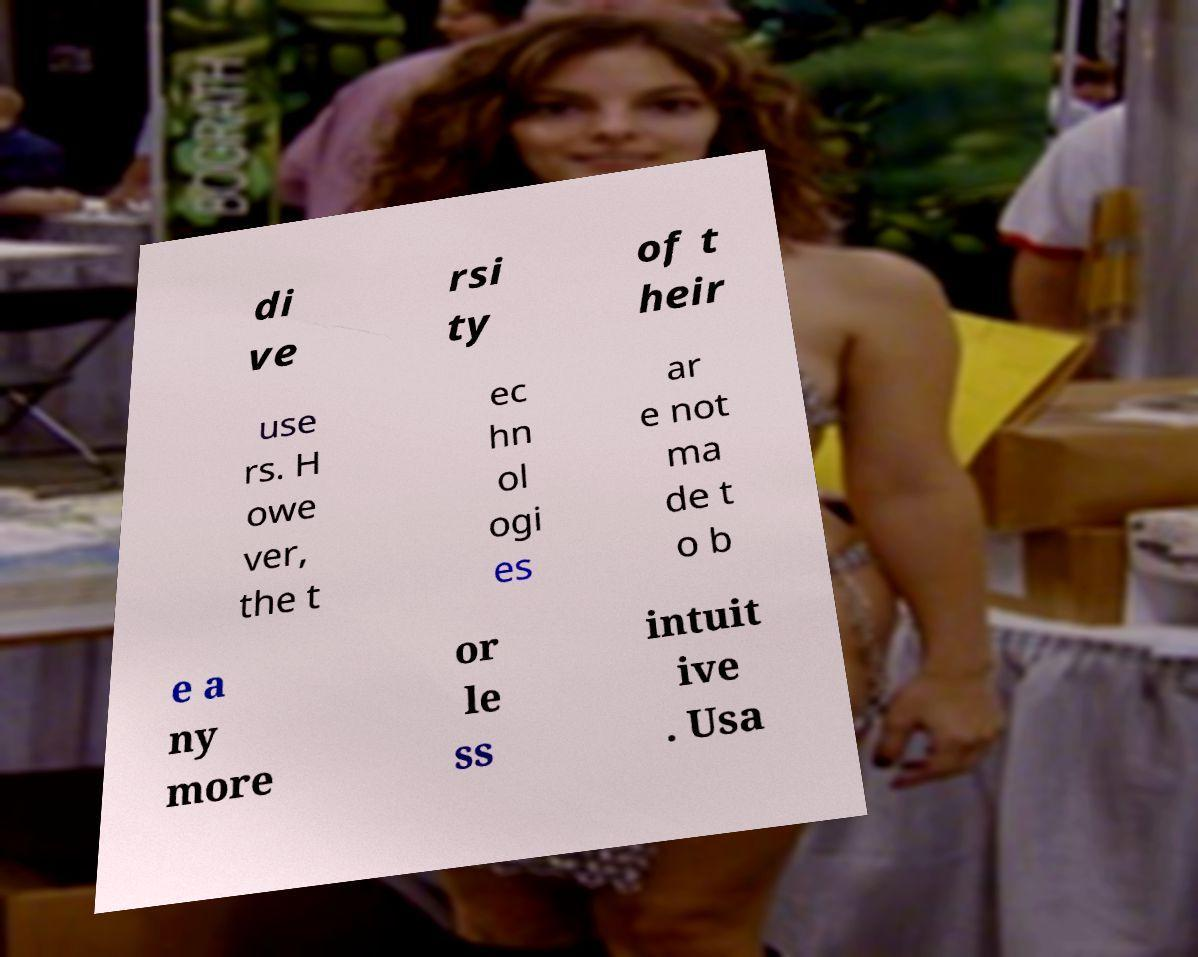Could you assist in decoding the text presented in this image and type it out clearly? di ve rsi ty of t heir use rs. H owe ver, the t ec hn ol ogi es ar e not ma de t o b e a ny more or le ss intuit ive . Usa 